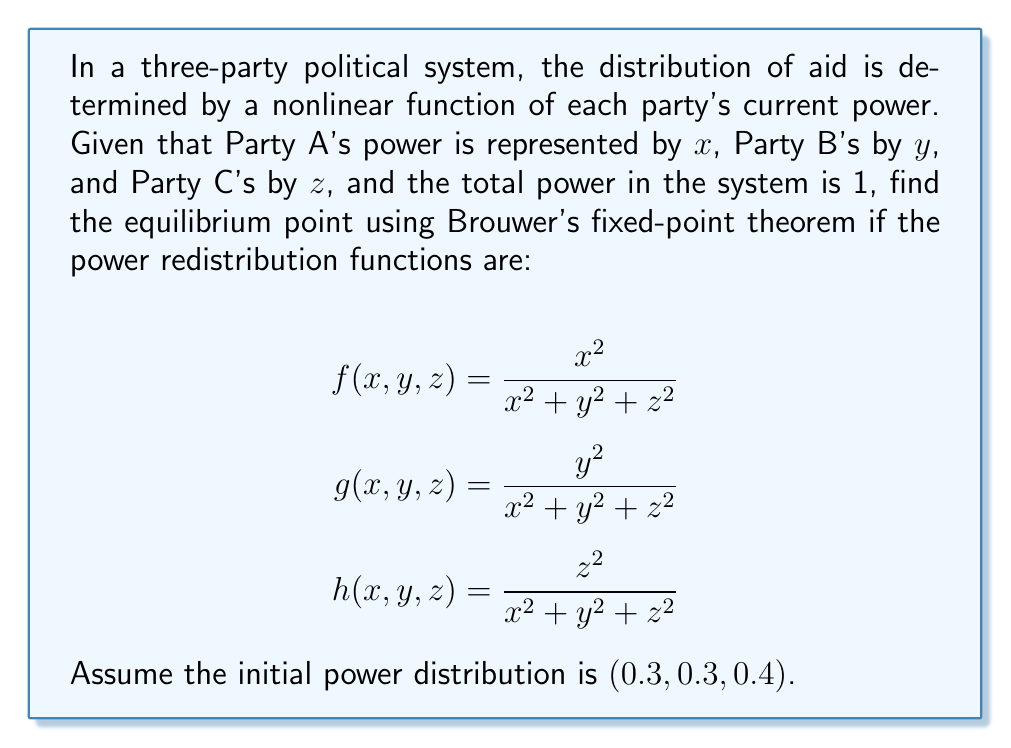Show me your answer to this math problem. To solve this problem, we'll use Brouwer's fixed-point theorem and an iterative approach:

1) First, note that $x + y + z = 1$ (total power is 1).

2) The functions $f$, $g$, and $h$ map the 2-simplex (triangle) to itself, satisfying the conditions for Brouwer's theorem.

3) We'll use the iteration method:
   $x_{n+1} = f(x_n, y_n, z_n)$
   $y_{n+1} = g(x_n, y_n, z_n)$
   $z_{n+1} = h(x_n, y_n, z_n)$

4) Starting with $(x_0, y_0, z_0) = (0.3, 0.3, 0.4)$:

   Iteration 1:
   $x_1 = \frac{0.3^2}{0.3^2+0.3^2+0.4^2} = 0.2813$
   $y_1 = \frac{0.3^2}{0.3^2+0.3^2+0.4^2} = 0.2813$
   $z_1 = \frac{0.4^2}{0.3^2+0.3^2+0.4^2} = 0.4375$

   Iteration 2:
   $x_2 = \frac{0.2813^2}{0.2813^2+0.2813^2+0.4375^2} = 0.2635$
   $y_2 = \frac{0.2813^2}{0.2813^2+0.2813^2+0.4375^2} = 0.2635$
   $z_2 = \frac{0.4375^2}{0.2813^2+0.2813^2+0.4375^2} = 0.4729$

5) Continuing this process, the values converge to the equilibrium point.

6) The equilibrium point satisfies:
   $x = \frac{x^2}{x^2+y^2+z^2}$
   $y = \frac{y^2}{x^2+y^2+z^2}$
   $z = \frac{z^2}{x^2+y^2+z^2}$

7) Solving this system (or continuing iterations), we find the equilibrium point.
Answer: $(0.25, 0.25, 0.5)$ 